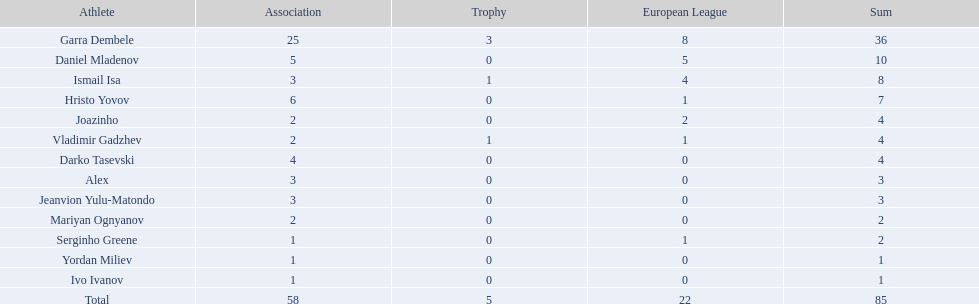What players did not score in all 3 competitions? Daniel Mladenov, Hristo Yovov, Joazinho, Darko Tasevski, Alex, Jeanvion Yulu-Matondo, Mariyan Ognyanov, Serginho Greene, Yordan Miliev, Ivo Ivanov. Which of those did not have total more then 5? Darko Tasevski, Alex, Jeanvion Yulu-Matondo, Mariyan Ognyanov, Serginho Greene, Yordan Miliev, Ivo Ivanov. Which ones scored more then 1 total? Darko Tasevski, Alex, Jeanvion Yulu-Matondo, Mariyan Ognyanov. Which of these player had the lease league points? Mariyan Ognyanov. 